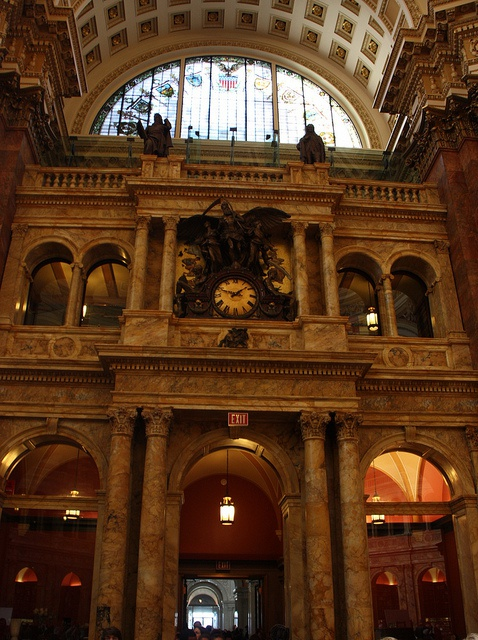Describe the objects in this image and their specific colors. I can see clock in maroon, olive, and black tones, people in maroon, black, navy, and brown tones, and people in black and maroon tones in this image. 